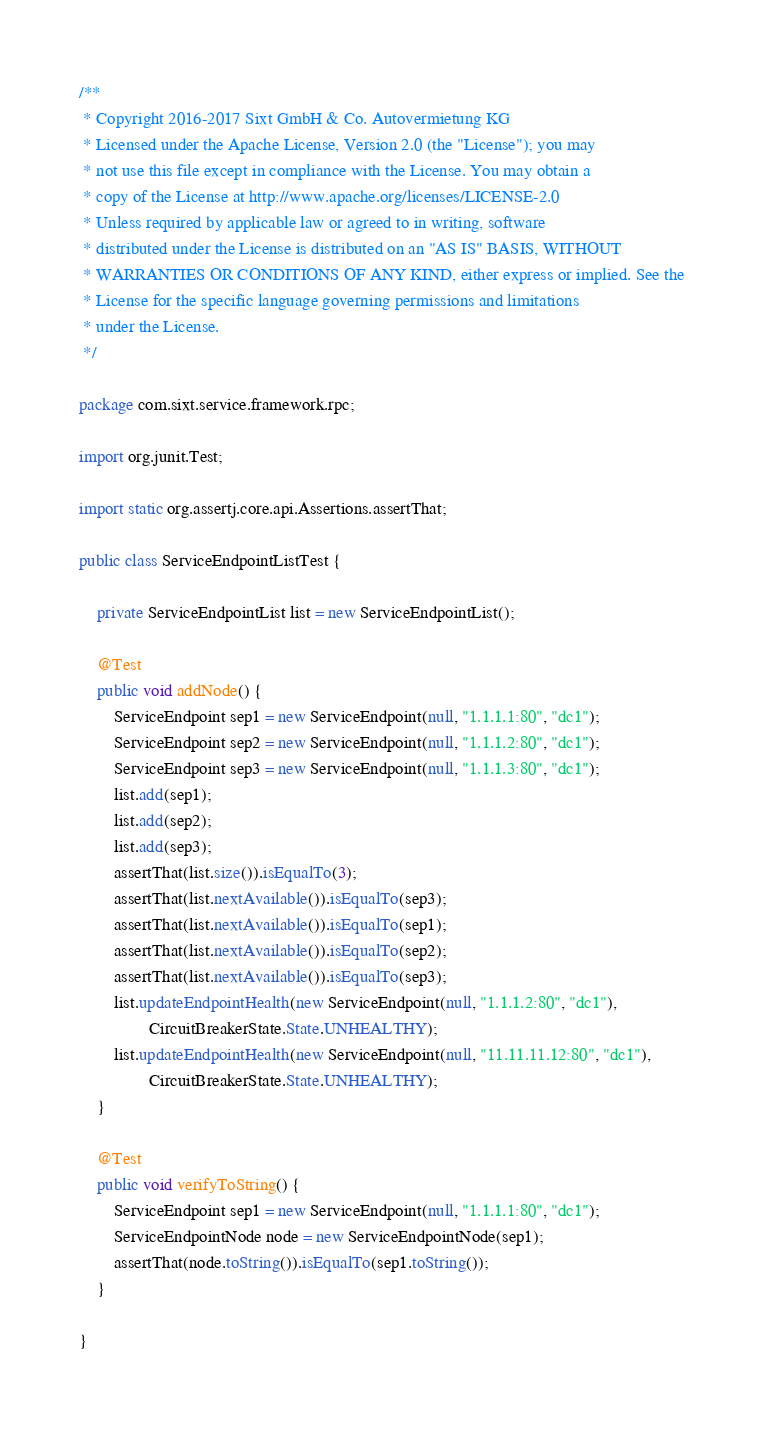Convert code to text. <code><loc_0><loc_0><loc_500><loc_500><_Java_>/**
 * Copyright 2016-2017 Sixt GmbH & Co. Autovermietung KG
 * Licensed under the Apache License, Version 2.0 (the "License"); you may 
 * not use this file except in compliance with the License. You may obtain a 
 * copy of the License at http://www.apache.org/licenses/LICENSE-2.0
 * Unless required by applicable law or agreed to in writing, software 
 * distributed under the License is distributed on an "AS IS" BASIS, WITHOUT 
 * WARRANTIES OR CONDITIONS OF ANY KIND, either express or implied. See the 
 * License for the specific language governing permissions and limitations 
 * under the License.
 */

package com.sixt.service.framework.rpc;

import org.junit.Test;

import static org.assertj.core.api.Assertions.assertThat;

public class ServiceEndpointListTest {

    private ServiceEndpointList list = new ServiceEndpointList();

    @Test
    public void addNode() {
        ServiceEndpoint sep1 = new ServiceEndpoint(null, "1.1.1.1:80", "dc1");
        ServiceEndpoint sep2 = new ServiceEndpoint(null, "1.1.1.2:80", "dc1");
        ServiceEndpoint sep3 = new ServiceEndpoint(null, "1.1.1.3:80", "dc1");
        list.add(sep1);
        list.add(sep2);
        list.add(sep3);
        assertThat(list.size()).isEqualTo(3);
        assertThat(list.nextAvailable()).isEqualTo(sep3);
        assertThat(list.nextAvailable()).isEqualTo(sep1);
        assertThat(list.nextAvailable()).isEqualTo(sep2);
        assertThat(list.nextAvailable()).isEqualTo(sep3);
        list.updateEndpointHealth(new ServiceEndpoint(null, "1.1.1.2:80", "dc1"),
                CircuitBreakerState.State.UNHEALTHY);
        list.updateEndpointHealth(new ServiceEndpoint(null, "11.11.11.12:80", "dc1"),
                CircuitBreakerState.State.UNHEALTHY);
    }

    @Test
    public void verifyToString() {
        ServiceEndpoint sep1 = new ServiceEndpoint(null, "1.1.1.1:80", "dc1");
        ServiceEndpointNode node = new ServiceEndpointNode(sep1);
        assertThat(node.toString()).isEqualTo(sep1.toString());
    }

}</code> 